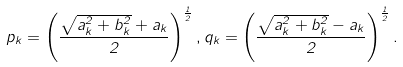Convert formula to latex. <formula><loc_0><loc_0><loc_500><loc_500>p _ { k } = \left ( \frac { \sqrt { a ^ { 2 } _ { k } + b ^ { 2 } _ { k } } + a _ { k } } { 2 } \right ) ^ { \frac { 1 } { 2 } } , q _ { k } = \left ( \frac { \sqrt { a ^ { 2 } _ { k } + b ^ { 2 } _ { k } } - a _ { k } } { 2 } \right ) ^ { \frac { 1 } { 2 } } .</formula> 